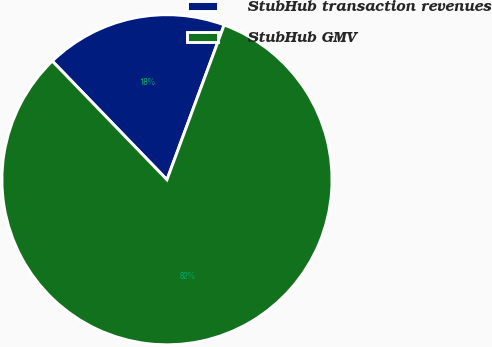<chart> <loc_0><loc_0><loc_500><loc_500><pie_chart><fcel>StubHub transaction revenues<fcel>StubHub GMV<nl><fcel>17.86%<fcel>82.14%<nl></chart> 